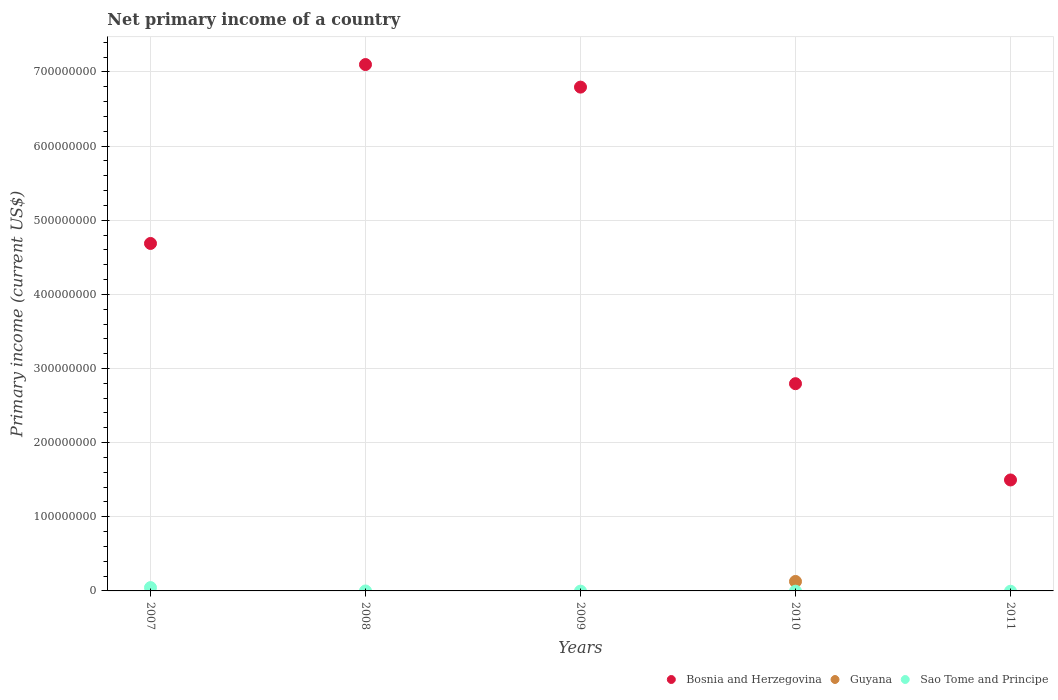Is the number of dotlines equal to the number of legend labels?
Offer a terse response. No. What is the primary income in Bosnia and Herzegovina in 2009?
Keep it short and to the point. 6.80e+08. Across all years, what is the maximum primary income in Bosnia and Herzegovina?
Provide a succinct answer. 7.10e+08. Across all years, what is the minimum primary income in Bosnia and Herzegovina?
Offer a very short reply. 1.50e+08. In which year was the primary income in Bosnia and Herzegovina maximum?
Keep it short and to the point. 2008. What is the total primary income in Bosnia and Herzegovina in the graph?
Ensure brevity in your answer.  2.29e+09. What is the difference between the primary income in Bosnia and Herzegovina in 2009 and that in 2011?
Make the answer very short. 5.30e+08. What is the difference between the primary income in Sao Tome and Principe in 2011 and the primary income in Guyana in 2010?
Your answer should be very brief. -1.28e+07. What is the average primary income in Sao Tome and Principe per year?
Offer a very short reply. 8.95e+05. In the year 2007, what is the difference between the primary income in Sao Tome and Principe and primary income in Bosnia and Herzegovina?
Your answer should be compact. -4.64e+08. In how many years, is the primary income in Sao Tome and Principe greater than 200000000 US$?
Provide a short and direct response. 0. What is the difference between the highest and the second highest primary income in Bosnia and Herzegovina?
Provide a succinct answer. 3.04e+07. What is the difference between the highest and the lowest primary income in Sao Tome and Principe?
Offer a terse response. 4.47e+06. Is the sum of the primary income in Bosnia and Herzegovina in 2008 and 2011 greater than the maximum primary income in Sao Tome and Principe across all years?
Your answer should be very brief. Yes. Is it the case that in every year, the sum of the primary income in Guyana and primary income in Sao Tome and Principe  is greater than the primary income in Bosnia and Herzegovina?
Give a very brief answer. No. Does the primary income in Guyana monotonically increase over the years?
Your response must be concise. No. How many dotlines are there?
Give a very brief answer. 3. How many years are there in the graph?
Keep it short and to the point. 5. Does the graph contain any zero values?
Give a very brief answer. Yes. Where does the legend appear in the graph?
Offer a very short reply. Bottom right. What is the title of the graph?
Your response must be concise. Net primary income of a country. Does "Estonia" appear as one of the legend labels in the graph?
Keep it short and to the point. No. What is the label or title of the X-axis?
Provide a short and direct response. Years. What is the label or title of the Y-axis?
Ensure brevity in your answer.  Primary income (current US$). What is the Primary income (current US$) of Bosnia and Herzegovina in 2007?
Provide a short and direct response. 4.69e+08. What is the Primary income (current US$) in Guyana in 2007?
Keep it short and to the point. 0. What is the Primary income (current US$) of Sao Tome and Principe in 2007?
Offer a terse response. 4.47e+06. What is the Primary income (current US$) of Bosnia and Herzegovina in 2008?
Offer a terse response. 7.10e+08. What is the Primary income (current US$) in Sao Tome and Principe in 2008?
Provide a short and direct response. 0. What is the Primary income (current US$) of Bosnia and Herzegovina in 2009?
Your response must be concise. 6.80e+08. What is the Primary income (current US$) in Bosnia and Herzegovina in 2010?
Ensure brevity in your answer.  2.80e+08. What is the Primary income (current US$) in Guyana in 2010?
Make the answer very short. 1.28e+07. What is the Primary income (current US$) of Sao Tome and Principe in 2010?
Provide a succinct answer. 0. What is the Primary income (current US$) of Bosnia and Herzegovina in 2011?
Your answer should be compact. 1.50e+08. What is the Primary income (current US$) in Guyana in 2011?
Provide a short and direct response. 0. Across all years, what is the maximum Primary income (current US$) in Bosnia and Herzegovina?
Keep it short and to the point. 7.10e+08. Across all years, what is the maximum Primary income (current US$) in Guyana?
Make the answer very short. 1.28e+07. Across all years, what is the maximum Primary income (current US$) of Sao Tome and Principe?
Offer a very short reply. 4.47e+06. Across all years, what is the minimum Primary income (current US$) in Bosnia and Herzegovina?
Ensure brevity in your answer.  1.50e+08. Across all years, what is the minimum Primary income (current US$) of Sao Tome and Principe?
Provide a succinct answer. 0. What is the total Primary income (current US$) of Bosnia and Herzegovina in the graph?
Your answer should be compact. 2.29e+09. What is the total Primary income (current US$) of Guyana in the graph?
Your answer should be compact. 1.28e+07. What is the total Primary income (current US$) in Sao Tome and Principe in the graph?
Your answer should be very brief. 4.47e+06. What is the difference between the Primary income (current US$) in Bosnia and Herzegovina in 2007 and that in 2008?
Make the answer very short. -2.41e+08. What is the difference between the Primary income (current US$) in Bosnia and Herzegovina in 2007 and that in 2009?
Provide a succinct answer. -2.11e+08. What is the difference between the Primary income (current US$) in Bosnia and Herzegovina in 2007 and that in 2010?
Your answer should be very brief. 1.89e+08. What is the difference between the Primary income (current US$) of Bosnia and Herzegovina in 2007 and that in 2011?
Give a very brief answer. 3.19e+08. What is the difference between the Primary income (current US$) in Bosnia and Herzegovina in 2008 and that in 2009?
Keep it short and to the point. 3.04e+07. What is the difference between the Primary income (current US$) of Bosnia and Herzegovina in 2008 and that in 2010?
Your response must be concise. 4.30e+08. What is the difference between the Primary income (current US$) in Bosnia and Herzegovina in 2008 and that in 2011?
Keep it short and to the point. 5.60e+08. What is the difference between the Primary income (current US$) in Bosnia and Herzegovina in 2009 and that in 2010?
Provide a succinct answer. 4.00e+08. What is the difference between the Primary income (current US$) of Bosnia and Herzegovina in 2009 and that in 2011?
Provide a succinct answer. 5.30e+08. What is the difference between the Primary income (current US$) in Bosnia and Herzegovina in 2010 and that in 2011?
Give a very brief answer. 1.30e+08. What is the difference between the Primary income (current US$) in Bosnia and Herzegovina in 2007 and the Primary income (current US$) in Guyana in 2010?
Provide a short and direct response. 4.56e+08. What is the difference between the Primary income (current US$) in Bosnia and Herzegovina in 2008 and the Primary income (current US$) in Guyana in 2010?
Keep it short and to the point. 6.97e+08. What is the difference between the Primary income (current US$) in Bosnia and Herzegovina in 2009 and the Primary income (current US$) in Guyana in 2010?
Your answer should be compact. 6.67e+08. What is the average Primary income (current US$) in Bosnia and Herzegovina per year?
Your response must be concise. 4.57e+08. What is the average Primary income (current US$) in Guyana per year?
Ensure brevity in your answer.  2.56e+06. What is the average Primary income (current US$) of Sao Tome and Principe per year?
Provide a succinct answer. 8.95e+05. In the year 2007, what is the difference between the Primary income (current US$) of Bosnia and Herzegovina and Primary income (current US$) of Sao Tome and Principe?
Your answer should be compact. 4.64e+08. In the year 2010, what is the difference between the Primary income (current US$) of Bosnia and Herzegovina and Primary income (current US$) of Guyana?
Your answer should be compact. 2.67e+08. What is the ratio of the Primary income (current US$) in Bosnia and Herzegovina in 2007 to that in 2008?
Provide a succinct answer. 0.66. What is the ratio of the Primary income (current US$) in Bosnia and Herzegovina in 2007 to that in 2009?
Your answer should be compact. 0.69. What is the ratio of the Primary income (current US$) in Bosnia and Herzegovina in 2007 to that in 2010?
Provide a short and direct response. 1.68. What is the ratio of the Primary income (current US$) of Bosnia and Herzegovina in 2007 to that in 2011?
Provide a short and direct response. 3.13. What is the ratio of the Primary income (current US$) of Bosnia and Herzegovina in 2008 to that in 2009?
Give a very brief answer. 1.04. What is the ratio of the Primary income (current US$) of Bosnia and Herzegovina in 2008 to that in 2010?
Offer a very short reply. 2.54. What is the ratio of the Primary income (current US$) of Bosnia and Herzegovina in 2008 to that in 2011?
Ensure brevity in your answer.  4.74. What is the ratio of the Primary income (current US$) in Bosnia and Herzegovina in 2009 to that in 2010?
Your response must be concise. 2.43. What is the ratio of the Primary income (current US$) of Bosnia and Herzegovina in 2009 to that in 2011?
Give a very brief answer. 4.54. What is the ratio of the Primary income (current US$) in Bosnia and Herzegovina in 2010 to that in 2011?
Your answer should be very brief. 1.87. What is the difference between the highest and the second highest Primary income (current US$) of Bosnia and Herzegovina?
Make the answer very short. 3.04e+07. What is the difference between the highest and the lowest Primary income (current US$) of Bosnia and Herzegovina?
Ensure brevity in your answer.  5.60e+08. What is the difference between the highest and the lowest Primary income (current US$) in Guyana?
Your answer should be very brief. 1.28e+07. What is the difference between the highest and the lowest Primary income (current US$) in Sao Tome and Principe?
Provide a short and direct response. 4.47e+06. 